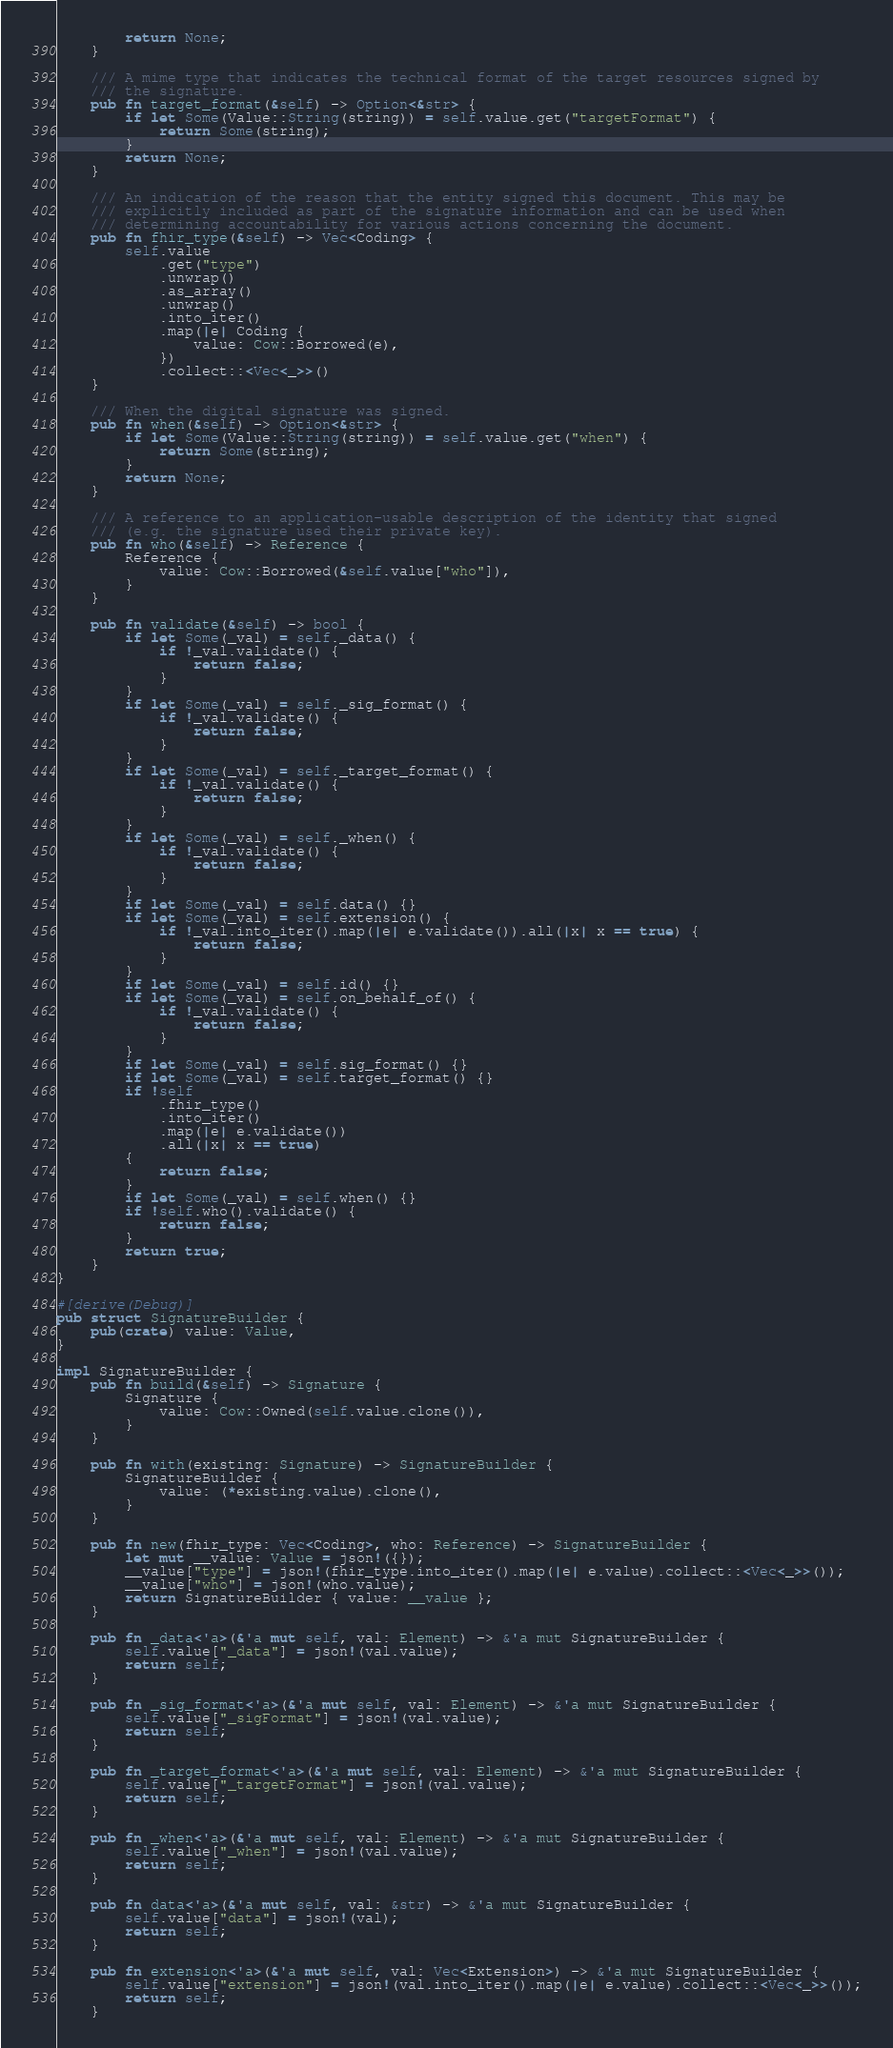Convert code to text. <code><loc_0><loc_0><loc_500><loc_500><_Rust_>        return None;
    }

    /// A mime type that indicates the technical format of the target resources signed by
    /// the signature.
    pub fn target_format(&self) -> Option<&str> {
        if let Some(Value::String(string)) = self.value.get("targetFormat") {
            return Some(string);
        }
        return None;
    }

    /// An indication of the reason that the entity signed this document. This may be
    /// explicitly included as part of the signature information and can be used when
    /// determining accountability for various actions concerning the document.
    pub fn fhir_type(&self) -> Vec<Coding> {
        self.value
            .get("type")
            .unwrap()
            .as_array()
            .unwrap()
            .into_iter()
            .map(|e| Coding {
                value: Cow::Borrowed(e),
            })
            .collect::<Vec<_>>()
    }

    /// When the digital signature was signed.
    pub fn when(&self) -> Option<&str> {
        if let Some(Value::String(string)) = self.value.get("when") {
            return Some(string);
        }
        return None;
    }

    /// A reference to an application-usable description of the identity that signed
    /// (e.g. the signature used their private key).
    pub fn who(&self) -> Reference {
        Reference {
            value: Cow::Borrowed(&self.value["who"]),
        }
    }

    pub fn validate(&self) -> bool {
        if let Some(_val) = self._data() {
            if !_val.validate() {
                return false;
            }
        }
        if let Some(_val) = self._sig_format() {
            if !_val.validate() {
                return false;
            }
        }
        if let Some(_val) = self._target_format() {
            if !_val.validate() {
                return false;
            }
        }
        if let Some(_val) = self._when() {
            if !_val.validate() {
                return false;
            }
        }
        if let Some(_val) = self.data() {}
        if let Some(_val) = self.extension() {
            if !_val.into_iter().map(|e| e.validate()).all(|x| x == true) {
                return false;
            }
        }
        if let Some(_val) = self.id() {}
        if let Some(_val) = self.on_behalf_of() {
            if !_val.validate() {
                return false;
            }
        }
        if let Some(_val) = self.sig_format() {}
        if let Some(_val) = self.target_format() {}
        if !self
            .fhir_type()
            .into_iter()
            .map(|e| e.validate())
            .all(|x| x == true)
        {
            return false;
        }
        if let Some(_val) = self.when() {}
        if !self.who().validate() {
            return false;
        }
        return true;
    }
}

#[derive(Debug)]
pub struct SignatureBuilder {
    pub(crate) value: Value,
}

impl SignatureBuilder {
    pub fn build(&self) -> Signature {
        Signature {
            value: Cow::Owned(self.value.clone()),
        }
    }

    pub fn with(existing: Signature) -> SignatureBuilder {
        SignatureBuilder {
            value: (*existing.value).clone(),
        }
    }

    pub fn new(fhir_type: Vec<Coding>, who: Reference) -> SignatureBuilder {
        let mut __value: Value = json!({});
        __value["type"] = json!(fhir_type.into_iter().map(|e| e.value).collect::<Vec<_>>());
        __value["who"] = json!(who.value);
        return SignatureBuilder { value: __value };
    }

    pub fn _data<'a>(&'a mut self, val: Element) -> &'a mut SignatureBuilder {
        self.value["_data"] = json!(val.value);
        return self;
    }

    pub fn _sig_format<'a>(&'a mut self, val: Element) -> &'a mut SignatureBuilder {
        self.value["_sigFormat"] = json!(val.value);
        return self;
    }

    pub fn _target_format<'a>(&'a mut self, val: Element) -> &'a mut SignatureBuilder {
        self.value["_targetFormat"] = json!(val.value);
        return self;
    }

    pub fn _when<'a>(&'a mut self, val: Element) -> &'a mut SignatureBuilder {
        self.value["_when"] = json!(val.value);
        return self;
    }

    pub fn data<'a>(&'a mut self, val: &str) -> &'a mut SignatureBuilder {
        self.value["data"] = json!(val);
        return self;
    }

    pub fn extension<'a>(&'a mut self, val: Vec<Extension>) -> &'a mut SignatureBuilder {
        self.value["extension"] = json!(val.into_iter().map(|e| e.value).collect::<Vec<_>>());
        return self;
    }
</code> 